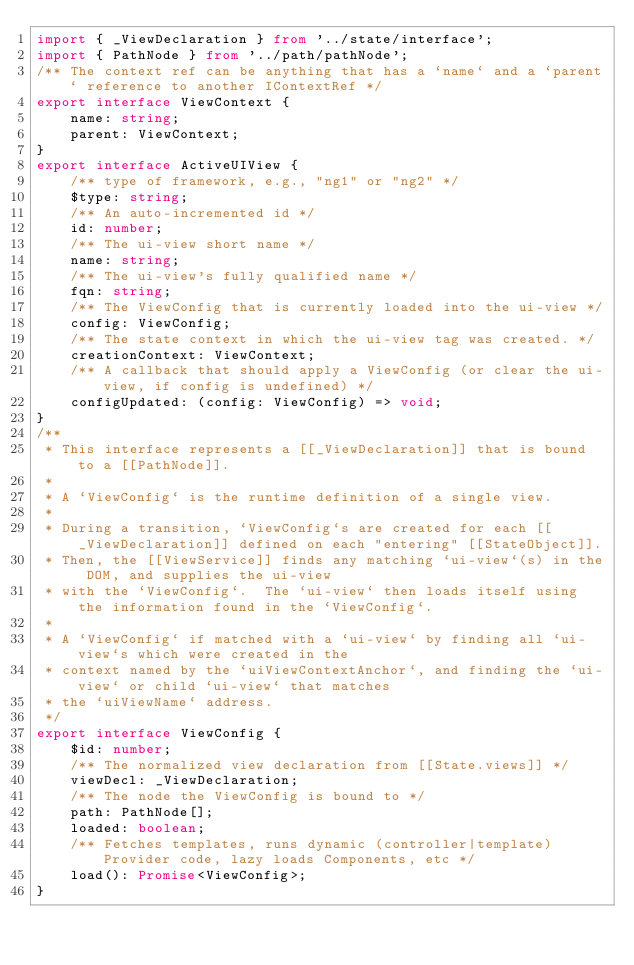Convert code to text. <code><loc_0><loc_0><loc_500><loc_500><_TypeScript_>import { _ViewDeclaration } from '../state/interface';
import { PathNode } from '../path/pathNode';
/** The context ref can be anything that has a `name` and a `parent` reference to another IContextRef */
export interface ViewContext {
    name: string;
    parent: ViewContext;
}
export interface ActiveUIView {
    /** type of framework, e.g., "ng1" or "ng2" */
    $type: string;
    /** An auto-incremented id */
    id: number;
    /** The ui-view short name */
    name: string;
    /** The ui-view's fully qualified name */
    fqn: string;
    /** The ViewConfig that is currently loaded into the ui-view */
    config: ViewConfig;
    /** The state context in which the ui-view tag was created. */
    creationContext: ViewContext;
    /** A callback that should apply a ViewConfig (or clear the ui-view, if config is undefined) */
    configUpdated: (config: ViewConfig) => void;
}
/**
 * This interface represents a [[_ViewDeclaration]] that is bound to a [[PathNode]].
 *
 * A `ViewConfig` is the runtime definition of a single view.
 *
 * During a transition, `ViewConfig`s are created for each [[_ViewDeclaration]] defined on each "entering" [[StateObject]].
 * Then, the [[ViewService]] finds any matching `ui-view`(s) in the DOM, and supplies the ui-view
 * with the `ViewConfig`.  The `ui-view` then loads itself using the information found in the `ViewConfig`.
 *
 * A `ViewConfig` if matched with a `ui-view` by finding all `ui-view`s which were created in the
 * context named by the `uiViewContextAnchor`, and finding the `ui-view` or child `ui-view` that matches
 * the `uiViewName` address.
 */
export interface ViewConfig {
    $id: number;
    /** The normalized view declaration from [[State.views]] */
    viewDecl: _ViewDeclaration;
    /** The node the ViewConfig is bound to */
    path: PathNode[];
    loaded: boolean;
    /** Fetches templates, runs dynamic (controller|template)Provider code, lazy loads Components, etc */
    load(): Promise<ViewConfig>;
}
</code> 